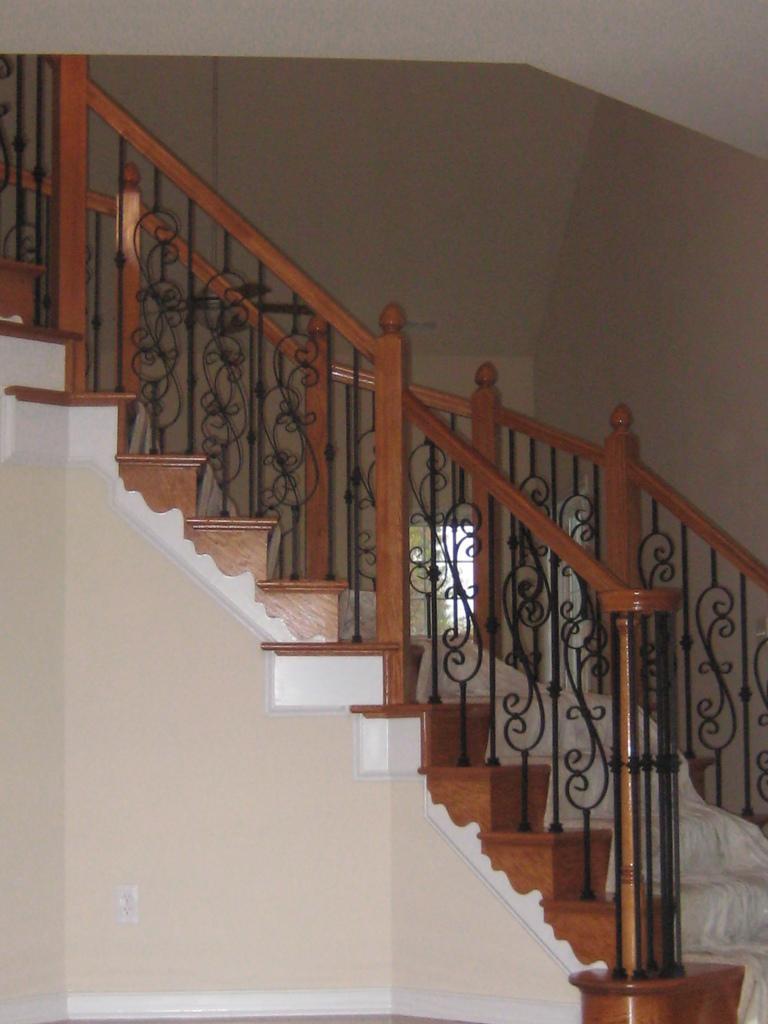How would you summarize this image in a sentence or two? In this image in the center there is a stair case and on the staircase there is one cloth, and there is a railing. And in the background there is wall and window. 